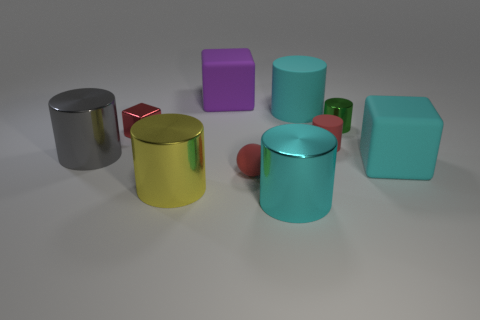Subtract all green cylinders. How many cylinders are left? 5 Subtract all large yellow cylinders. How many cylinders are left? 5 Subtract all brown cylinders. Subtract all blue cubes. How many cylinders are left? 6 Subtract all spheres. How many objects are left? 9 Add 8 cyan rubber objects. How many cyan rubber objects are left? 10 Add 8 small cubes. How many small cubes exist? 9 Subtract 0 brown cylinders. How many objects are left? 10 Subtract all large green rubber things. Subtract all large metallic objects. How many objects are left? 7 